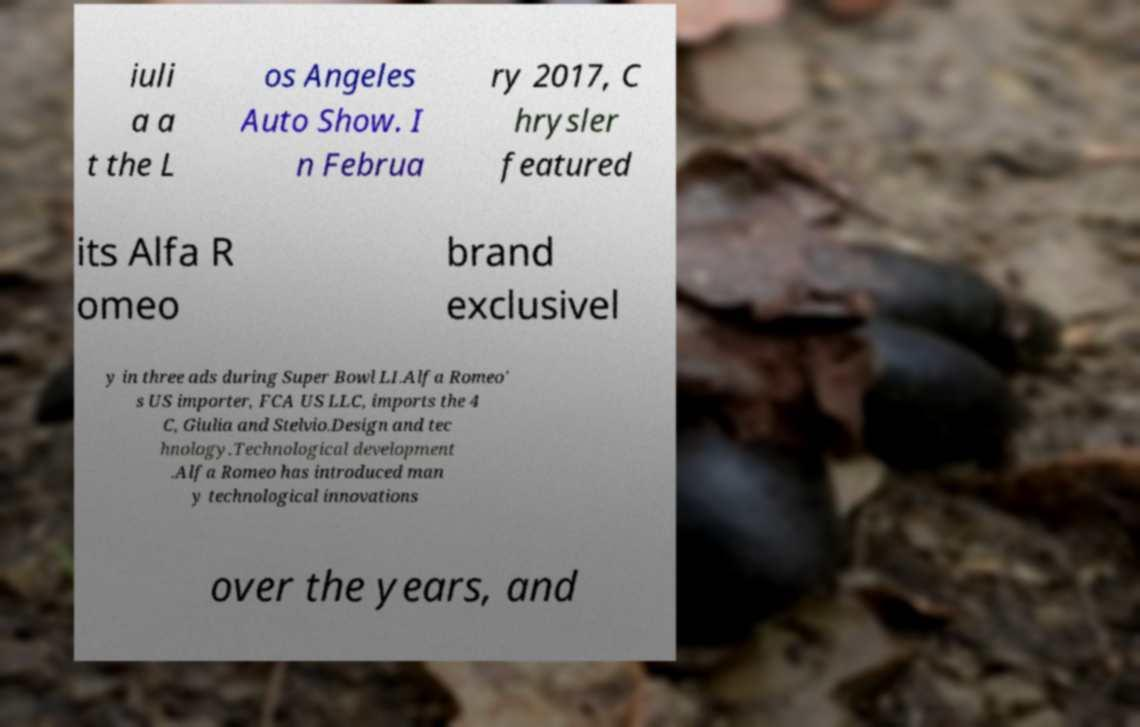Can you read and provide the text displayed in the image?This photo seems to have some interesting text. Can you extract and type it out for me? iuli a a t the L os Angeles Auto Show. I n Februa ry 2017, C hrysler featured its Alfa R omeo brand exclusivel y in three ads during Super Bowl LI.Alfa Romeo' s US importer, FCA US LLC, imports the 4 C, Giulia and Stelvio.Design and tec hnology.Technological development .Alfa Romeo has introduced man y technological innovations over the years, and 